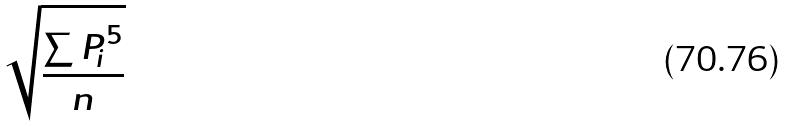<formula> <loc_0><loc_0><loc_500><loc_500>\sqrt { \frac { \sum { P _ { i } } ^ { 5 } } { n } }</formula> 